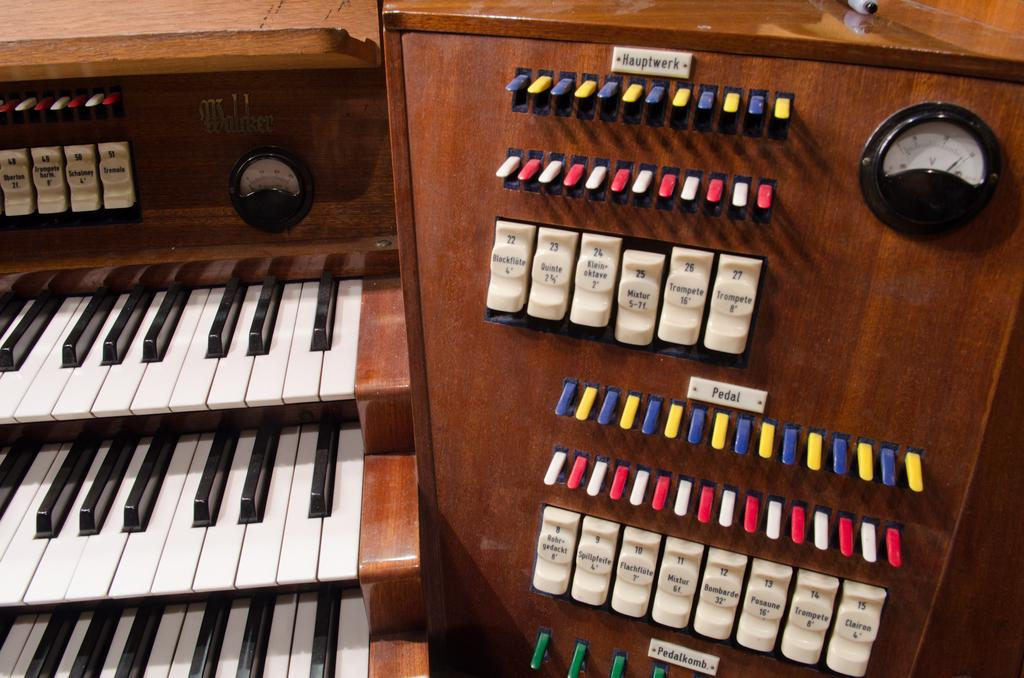What musical instrument is present in the image? There is a piano in the image. What additional features are attached to the piano? Meters are attached to the piano. How does one interact with the piano to produce sound? There are keys on the piano used to control the device. How many lizards can be seen crawling on the piano in the image? There are no lizards present in the image; it only features a piano with attached meters and keys. 